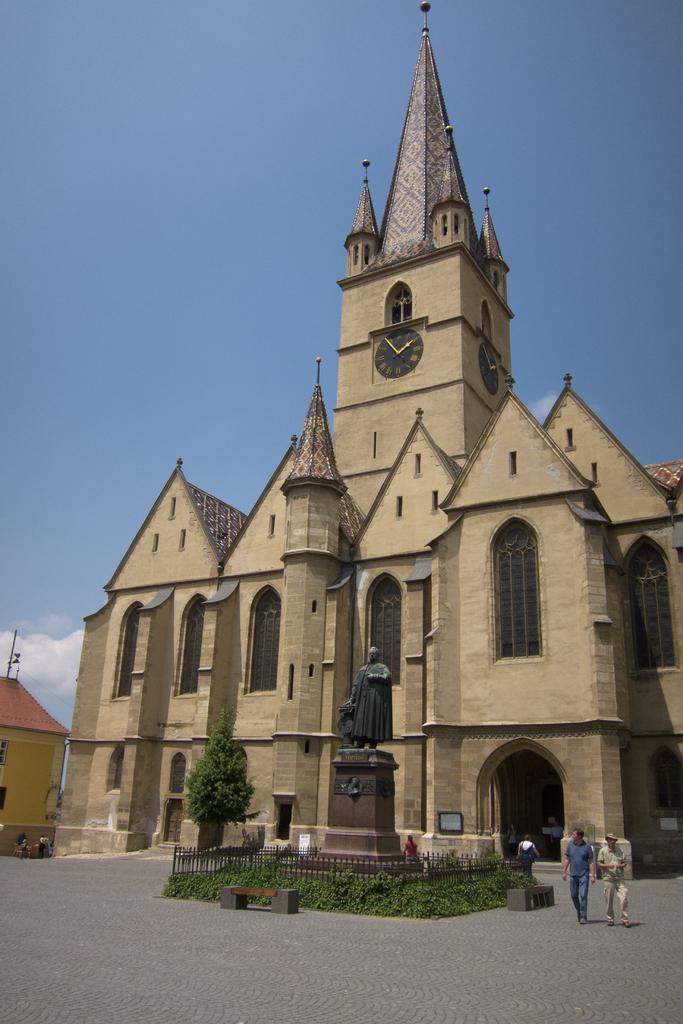How would you summarize this image in a sentence or two? This is a picture of the cathedral and there is a tree beside it. We can see a sculpture in front of the cathedral and it is surrounded by an iron fence and plants. There are few people inside the cathedral and two people are walking, there is a building beside the cathedral and the sky. 